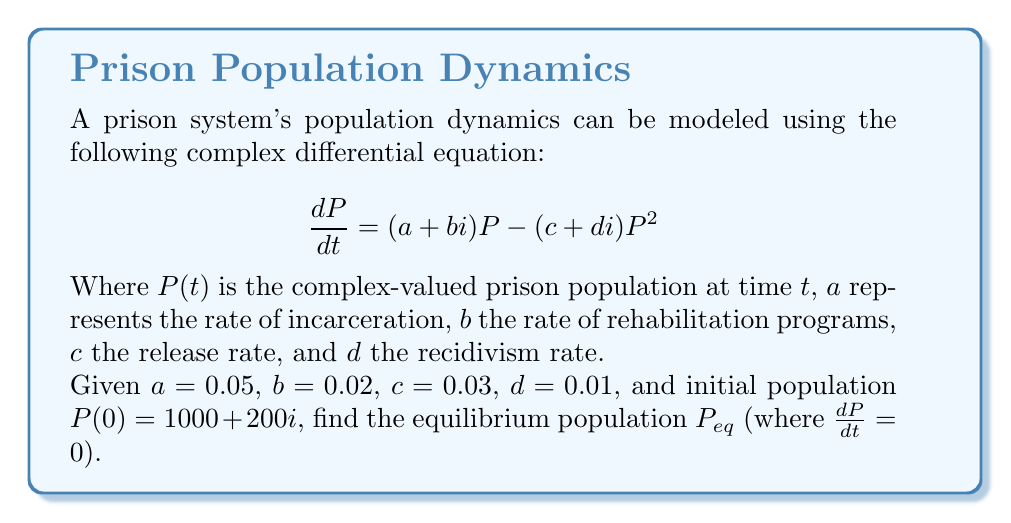Show me your answer to this math problem. To find the equilibrium population, we set $\frac{dP}{dt} = 0$:

1) $0 = (a + bi)P_{eq} - (c + di)P_{eq}^2$

2) Divide both sides by $P_{eq}$ (assuming $P_{eq} \neq 0$):
   $0 = (a + bi) - (c + di)P_{eq}$

3) Solve for $P_{eq}$:
   $(c + di)P_{eq} = a + bi$
   $P_{eq} = \frac{a + bi}{c + di}$

4) Multiply numerator and denominator by the complex conjugate of the denominator:
   $P_{eq} = \frac{(a + bi)(c - di)}{(c + di)(c - di)} = \frac{(ac + bd) + (bc - ad)i}{c^2 + d^2}$

5) Substitute the given values:
   $P_{eq} = \frac{(0.05 \cdot 0.03 + 0.02 \cdot 0.01) + (0.02 \cdot 0.03 - 0.05 \cdot 0.01)i}{0.03^2 + 0.01^2}$

6) Simplify:
   $P_{eq} = \frac{0.0017 + 0.0004i}{0.001}$

7) Final result:
   $P_{eq} = 1700 + 400i$
Answer: $P_{eq} = 1700 + 400i$ 